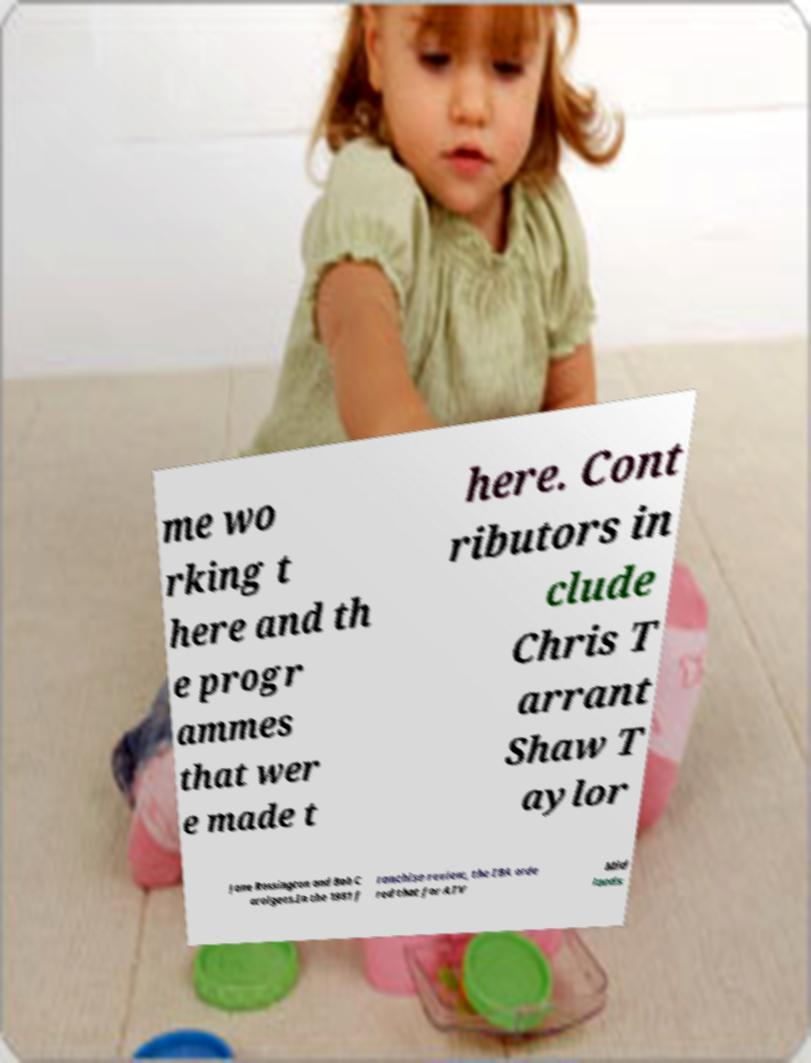Please identify and transcribe the text found in this image. me wo rking t here and th e progr ammes that wer e made t here. Cont ributors in clude Chris T arrant Shaw T aylor Jane Rossington and Bob C arolgees.In the 1981 f ranchise review, the IBA orde red that for ATV Mid lands 